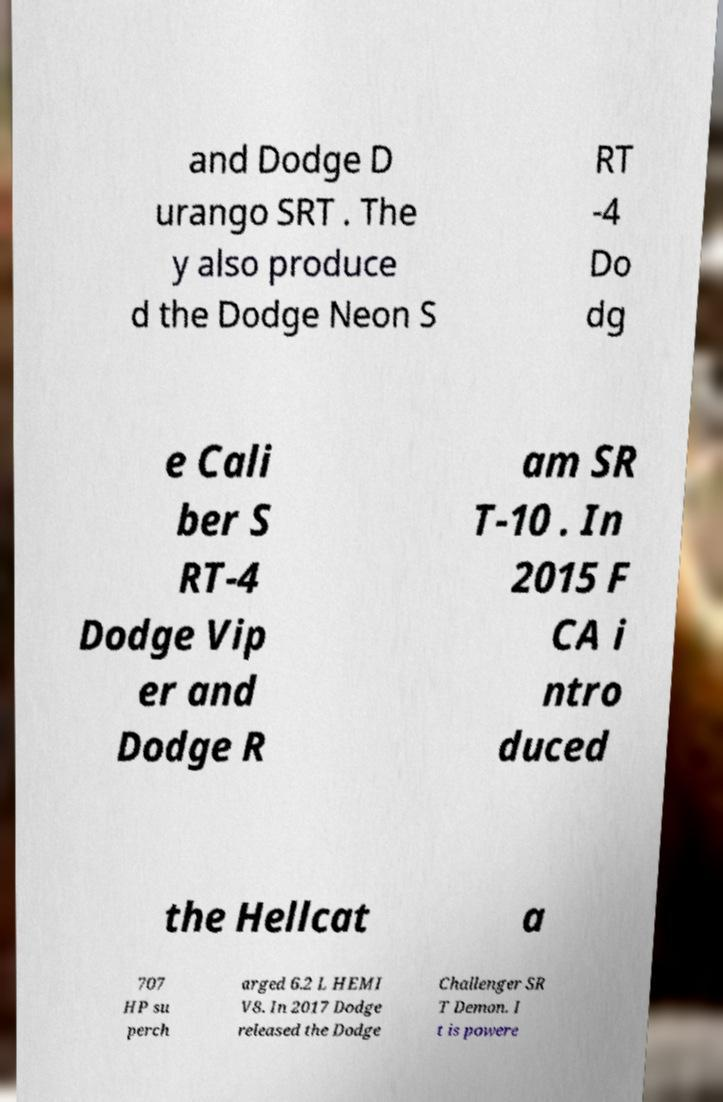What messages or text are displayed in this image? I need them in a readable, typed format. and Dodge D urango SRT . The y also produce d the Dodge Neon S RT -4 Do dg e Cali ber S RT-4 Dodge Vip er and Dodge R am SR T-10 . In 2015 F CA i ntro duced the Hellcat a 707 HP su perch arged 6.2 L HEMI V8. In 2017 Dodge released the Dodge Challenger SR T Demon. I t is powere 